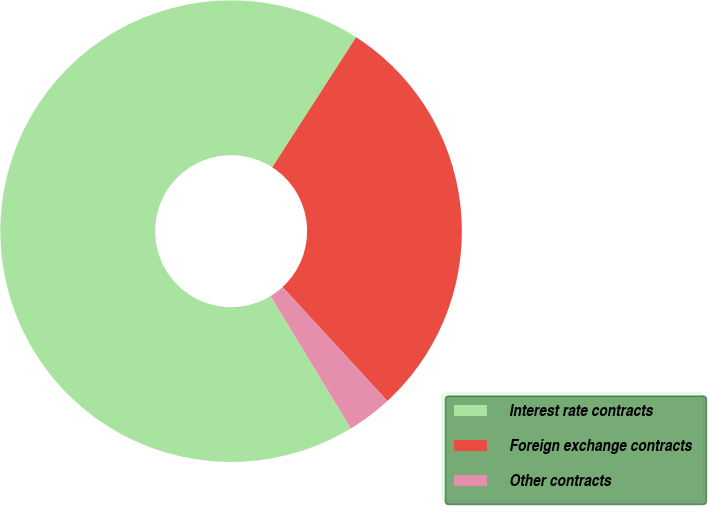<chart> <loc_0><loc_0><loc_500><loc_500><pie_chart><fcel>Interest rate contracts<fcel>Foreign exchange contracts<fcel>Other contracts<nl><fcel>67.79%<fcel>29.05%<fcel>3.15%<nl></chart> 